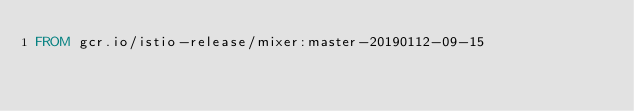Convert code to text. <code><loc_0><loc_0><loc_500><loc_500><_Dockerfile_>FROM gcr.io/istio-release/mixer:master-20190112-09-15
</code> 